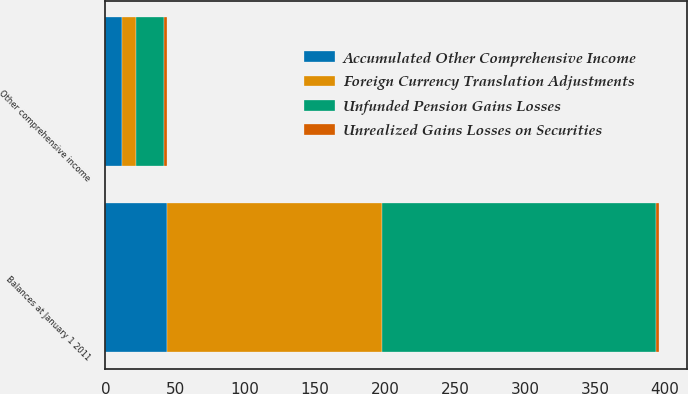Convert chart to OTSL. <chart><loc_0><loc_0><loc_500><loc_500><stacked_bar_chart><ecel><fcel>Balances at January 1 2011<fcel>Other comprehensive income<nl><fcel>Unrealized Gains Losses on Securities<fcel>2<fcel>2<nl><fcel>Accumulated Other Comprehensive Income<fcel>44<fcel>12<nl><fcel>Unfunded Pension Gains Losses<fcel>196<fcel>20<nl><fcel>Foreign Currency Translation Adjustments<fcel>154<fcel>10<nl></chart> 